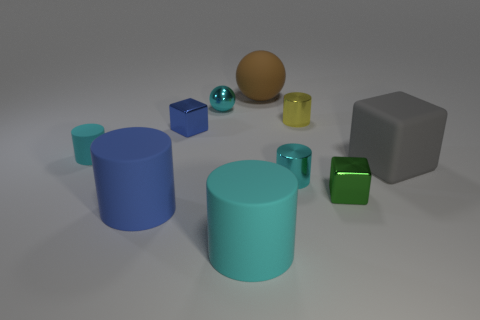What number of other objects are the same color as the small sphere?
Your response must be concise. 3. Are there any other things that have the same size as the gray rubber object?
Provide a short and direct response. Yes. Is the color of the small shiny ball the same as the large sphere?
Provide a short and direct response. No. What color is the small cube that is left of the large cylinder in front of the big blue cylinder?
Offer a terse response. Blue. How many tiny objects are either spheres or metallic cylinders?
Give a very brief answer. 3. There is a object that is in front of the big gray matte thing and on the right side of the yellow metallic cylinder; what is its color?
Keep it short and to the point. Green. Is the tiny cyan sphere made of the same material as the gray cube?
Offer a very short reply. No. The tiny rubber object is what shape?
Your answer should be very brief. Cylinder. There is a cyan shiny thing left of the small metallic cylinder in front of the small yellow shiny thing; how many small shiny things are to the left of it?
Keep it short and to the point. 1. There is another tiny rubber thing that is the same shape as the yellow object; what is its color?
Provide a succinct answer. Cyan. 